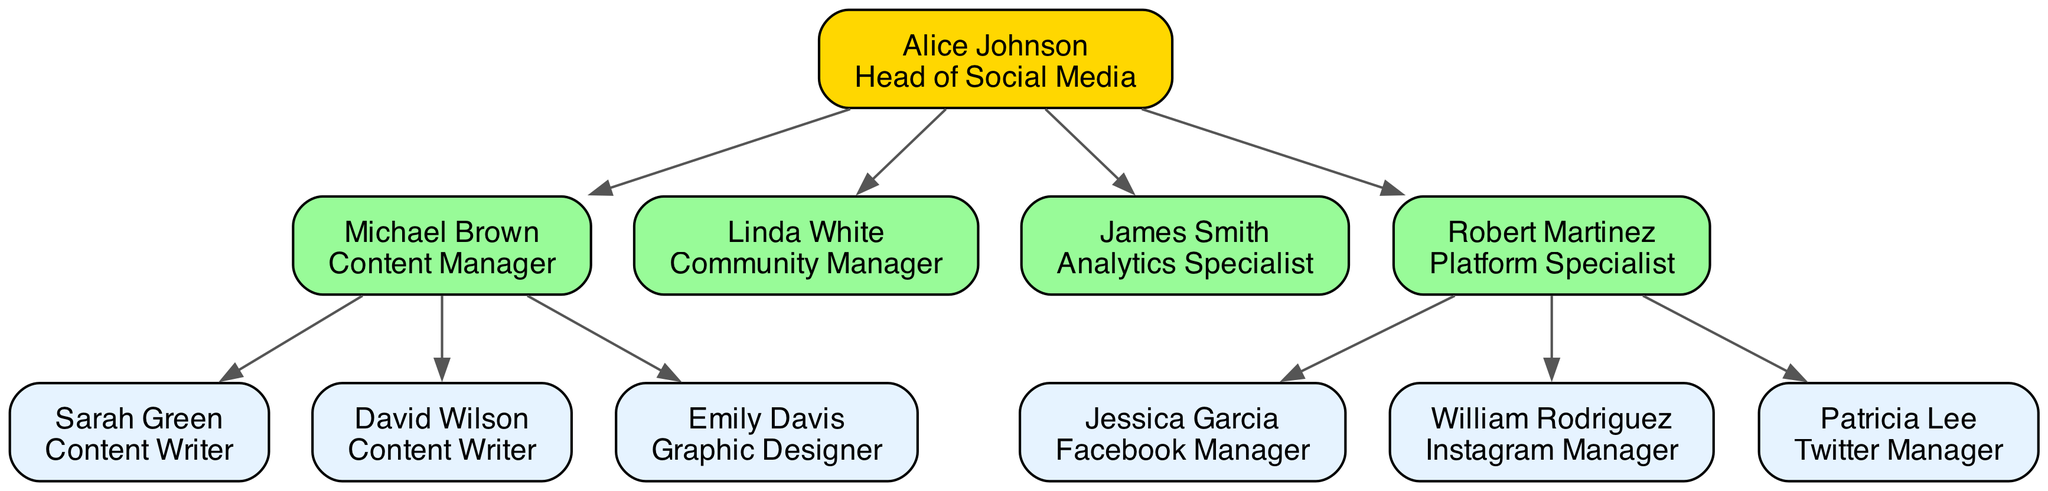What is the role of Alice Johnson? Alice Johnson is identified as the Head of Social Media in the diagram. This is the direct label shown under her name as the top node in the family tree.
Answer: Head of Social Media How many Content Writers report to Michael Brown? In the diagram, there are two individuals listed as Content Writers who directly report to Michael Brown: Sarah Green and David Wilson. Hence, by counting them, the answer is two.
Answer: 2 Who is responsible for managing Instagram? The diagram shows that William Rodriguez holds the role of Instagram Manager. He is directly under Robert Martinez, who is the Platform Specialist, indicating he is responsible for managing the Instagram platform.
Answer: William Rodriguez How many members report directly to Alice Johnson? According to the diagram, Alice Johnson has four direct reports: Michael Brown, Linda White, James Smith, and Robert Martinez. Counting these members gives the total of four.
Answer: 4 What is the relationship between Michael Brown and Emily Davis? The diagram indicates that Emily Davis is a Graphic Designer, and she reports to Michael Brown, who is the Content Manager. This establishes a reporting relationship where Emily is subordinate to Michael.
Answer: Subordinate relationship Which team member has no subordinates? The diagram shows both Linda White (Community Manager) and James Smith (Analytics Specialist) have no subordinates listed under them. Thus, either answer would be correct for members without any direct reports.
Answer: Linda White or James Smith How many Channel Managers are under Robert Martinez? There are three individuals listed as Channel Managers under Robert Martinez: Jessica Garcia (Facebook Manager), William Rodriguez (Instagram Manager), and Patricia Lee (Twitter Manager). This is a direct count of the subordinates shown in that section of the diagram.
Answer: 3 What role does Emily Davis fulfill in the team structure? Emily Davis is labeled as a Graphic Designer in the diagram, which specifies her role in the team structure directly under her name.
Answer: Graphic Designer Which role has the highest level of authority in this structure? The highest position in this family tree is that of Alice Johnson, who is the Head of Social Media. This indicates she has the most authority in the given team structure.
Answer: Head of Social Media 